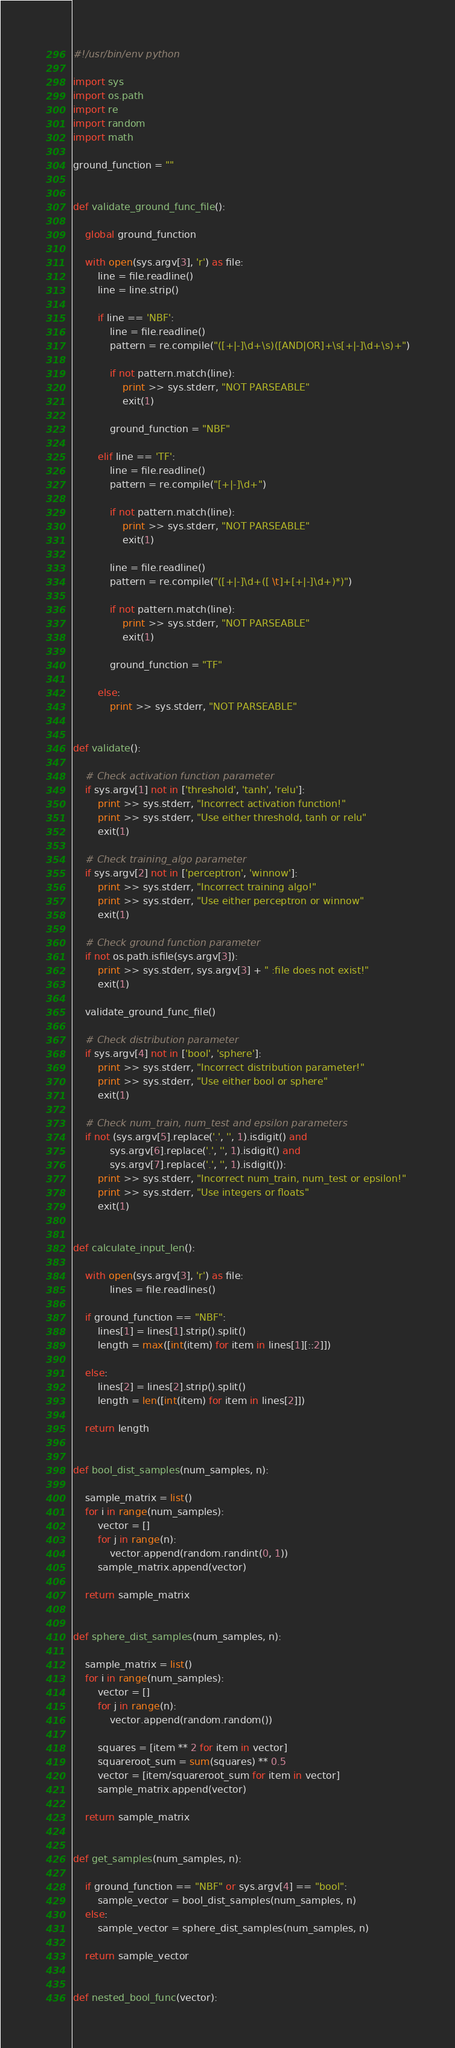Convert code to text. <code><loc_0><loc_0><loc_500><loc_500><_Python_>#!/usr/bin/env python

import sys
import os.path
import re
import random
import math

ground_function = ""


def validate_ground_func_file():

    global ground_function

    with open(sys.argv[3], 'r') as file:
        line = file.readline()
        line = line.strip()

        if line == 'NBF':
            line = file.readline()
            pattern = re.compile("([+|-]\d+\s)([AND|OR]+\s[+|-]\d+\s)+")

            if not pattern.match(line):
                print >> sys.stderr, "NOT PARSEABLE"
                exit(1)

            ground_function = "NBF"

        elif line == 'TF':
            line = file.readline()
            pattern = re.compile("[+|-]\d+")

            if not pattern.match(line):
                print >> sys.stderr, "NOT PARSEABLE"
                exit(1)

            line = file.readline()
            pattern = re.compile("([+|-]\d+([ \t]+[+|-]\d+)*)")

            if not pattern.match(line):
                print >> sys.stderr, "NOT PARSEABLE"
                exit(1)

            ground_function = "TF"

        else:
            print >> sys.stderr, "NOT PARSEABLE"


def validate():

    # Check activation function parameter
    if sys.argv[1] not in ['threshold', 'tanh', 'relu']:
        print >> sys.stderr, "Incorrect activation function!"
        print >> sys.stderr, "Use either threshold, tanh or relu"
        exit(1)

    # Check training_algo parameter
    if sys.argv[2] not in ['perceptron', 'winnow']:
        print >> sys.stderr, "Incorrect training algo!"
        print >> sys.stderr, "Use either perceptron or winnow"
        exit(1)

    # Check ground function parameter
    if not os.path.isfile(sys.argv[3]):
        print >> sys.stderr, sys.argv[3] + " :file does not exist!"
        exit(1)

    validate_ground_func_file()

    # Check distribution parameter
    if sys.argv[4] not in ['bool', 'sphere']:
        print >> sys.stderr, "Incorrect distribution parameter!"
        print >> sys.stderr, "Use either bool or sphere"
        exit(1)

    # Check num_train, num_test and epsilon parameters
    if not (sys.argv[5].replace('.', '', 1).isdigit() and
            sys.argv[6].replace('.', '', 1).isdigit() and
            sys.argv[7].replace('.', '', 1).isdigit()):
        print >> sys.stderr, "Incorrect num_train, num_test or epsilon!"
        print >> sys.stderr, "Use integers or floats"
        exit(1)


def calculate_input_len():

    with open(sys.argv[3], 'r') as file:
            lines = file.readlines()

    if ground_function == "NBF":
        lines[1] = lines[1].strip().split()
        length = max([int(item) for item in lines[1][::2]])

    else:
        lines[2] = lines[2].strip().split()
        length = len([int(item) for item in lines[2]])

    return length


def bool_dist_samples(num_samples, n):

    sample_matrix = list()
    for i in range(num_samples):
        vector = []
        for j in range(n):
            vector.append(random.randint(0, 1))
        sample_matrix.append(vector)

    return sample_matrix


def sphere_dist_samples(num_samples, n):

    sample_matrix = list()
    for i in range(num_samples):
        vector = []
        for j in range(n):
            vector.append(random.random())

        squares = [item ** 2 for item in vector]
        squareroot_sum = sum(squares) ** 0.5
        vector = [item/squareroot_sum for item in vector]
        sample_matrix.append(vector)

    return sample_matrix


def get_samples(num_samples, n):

    if ground_function == "NBF" or sys.argv[4] == "bool":
        sample_vector = bool_dist_samples(num_samples, n)
    else:
        sample_vector = sphere_dist_samples(num_samples, n)

    return sample_vector


def nested_bool_func(vector):</code> 